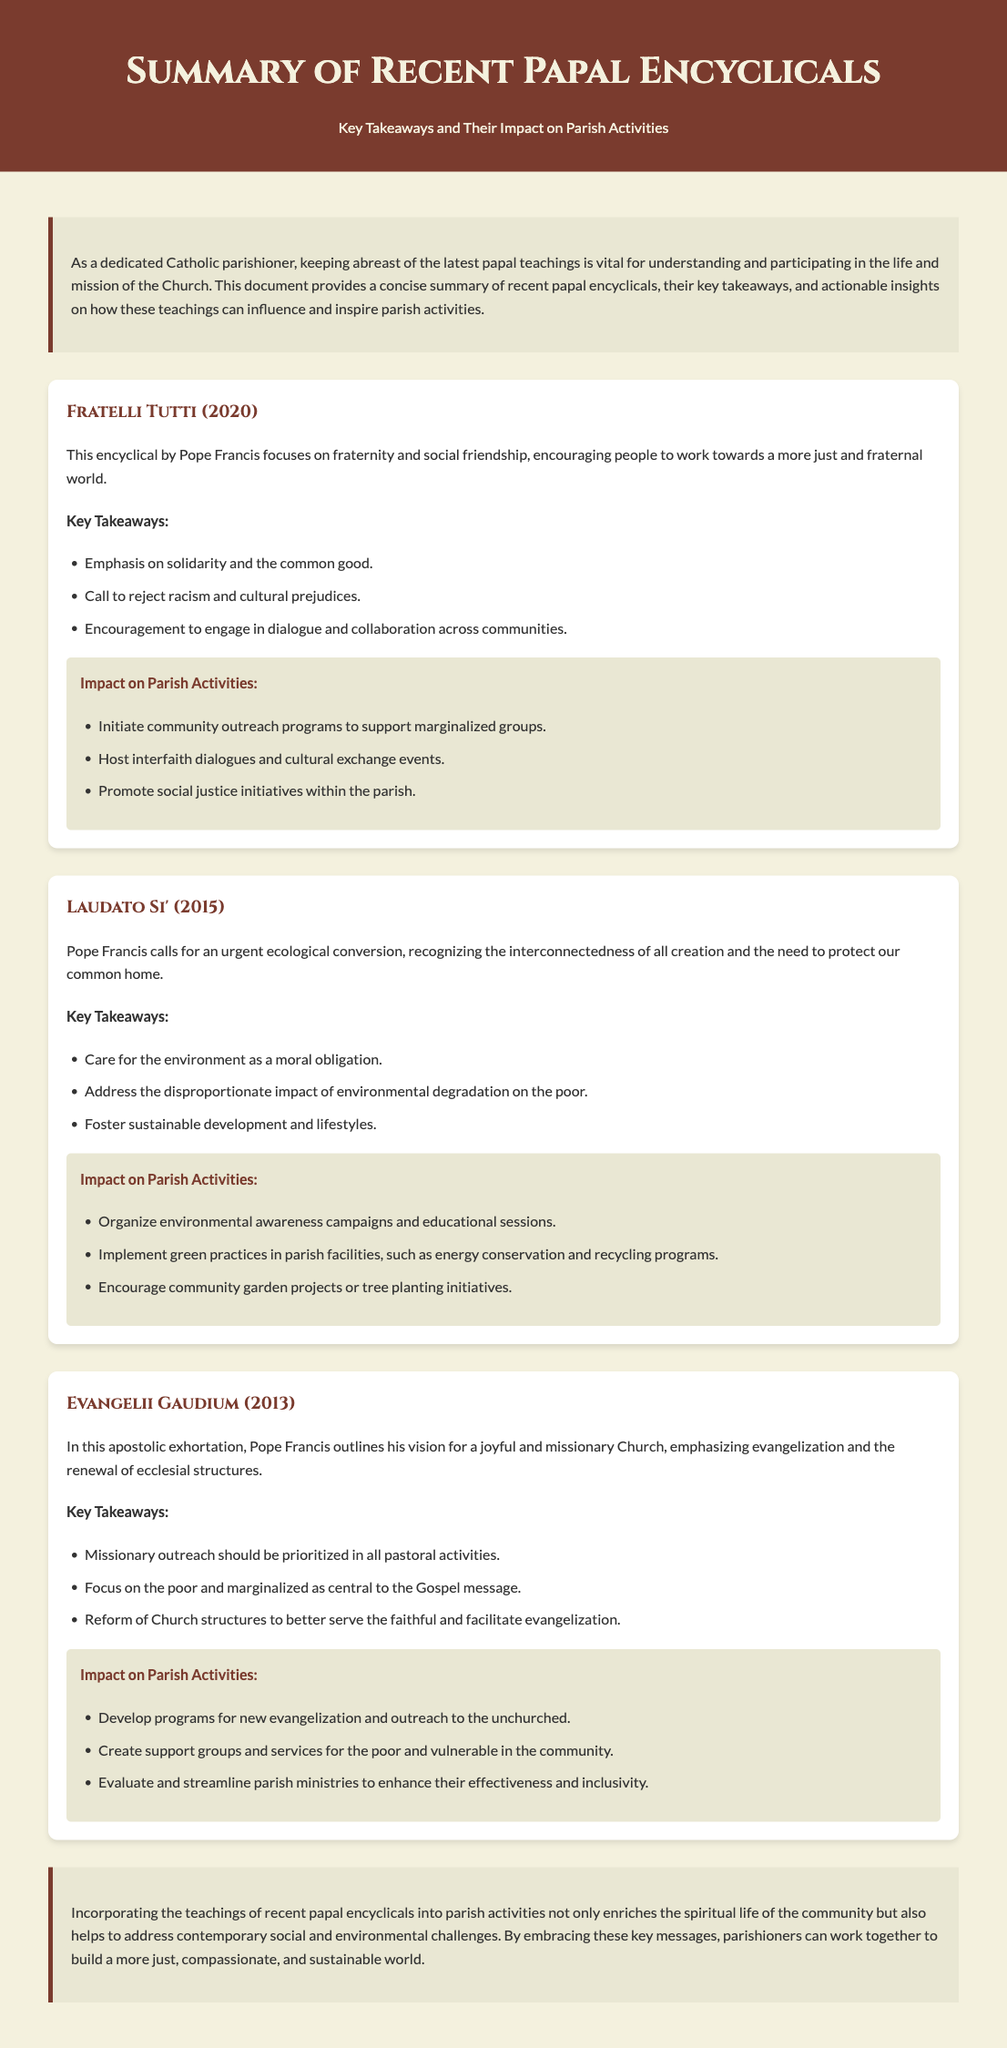What is the title of the first encyclical summarized? The document summarizes three recent papal encyclicals, starting with "Fratelli Tutti."
Answer: Fratelli Tutti Who wrote "Laudato Si'"? The document attributes "Laudato Si'" to Pope Francis.
Answer: Pope Francis What main theme does "Fratelli Tutti" emphasize? The key takeaway for "Fratelli Tutti" highlights solidarity and the common good.
Answer: Solidarity and the common good What type of initiatives are suggested for "Laudato Si'"? The impact section for "Laudato Si'" lists organizing environmental awareness campaigns as an initiative.
Answer: Environmental awareness campaigns How many encyclicals are summarized in the document? The document clearly identifies that it summarizes three encyclicals.
Answer: Three What kind of outreach is prioritized in "Evangelii Gaudium"? The key takeaway emphasizes that missionary outreach should be prioritized.
Answer: Missionary outreach What is the purpose of the document? The introduction explains that the document aims to provide a summary of recent papal encyclicals with actionable insights.
Answer: Summary of recent papal encyclicals with actionable insights What color is used for the header background? The header background color specified in the document is #7a3b2e.
Answer: #7a3b2e What moral obligation is highlighted in "Laudato Si'"? The encyclical specifies that care for the environment is presented as a moral obligation.
Answer: Care for the environment 